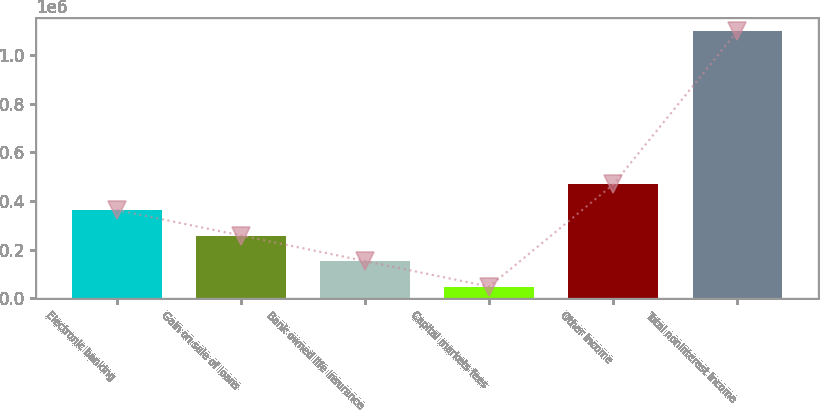Convert chart. <chart><loc_0><loc_0><loc_500><loc_500><bar_chart><fcel>Electronic banking<fcel>Gain on sale of loans<fcel>Bank owned life insurance<fcel>Capital markets fees<fcel>Other income<fcel>Total noninterest income<nl><fcel>363069<fcel>258099<fcel>153130<fcel>48160<fcel>468039<fcel>1.09786e+06<nl></chart> 